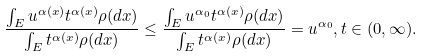<formula> <loc_0><loc_0><loc_500><loc_500>\frac { \int _ { E } u ^ { \alpha ( x ) } t ^ { \alpha ( x ) } \rho ( d x ) } { \int _ { E } t ^ { \alpha ( x ) } \rho ( d x ) } \leq \frac { \int _ { E } u ^ { \alpha _ { 0 } } t ^ { \alpha ( x ) } \rho ( d x ) } { \int _ { E } t ^ { \alpha ( x ) } \rho ( d x ) } = u ^ { \alpha _ { 0 } } , t \in ( 0 , \infty ) .</formula> 